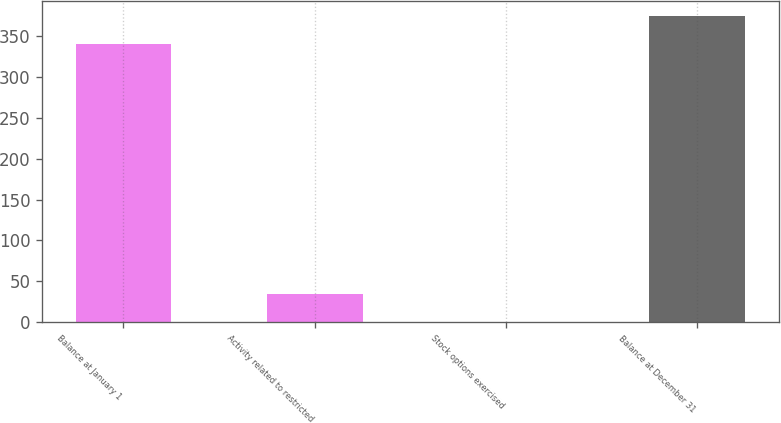Convert chart to OTSL. <chart><loc_0><loc_0><loc_500><loc_500><bar_chart><fcel>Balance at January 1<fcel>Activity related to restricted<fcel>Stock options exercised<fcel>Balance at December 31<nl><fcel>340<fcel>34.33<fcel>0.2<fcel>374.13<nl></chart> 